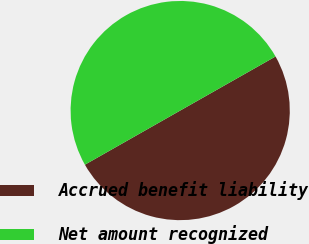Convert chart. <chart><loc_0><loc_0><loc_500><loc_500><pie_chart><fcel>Accrued benefit liability<fcel>Net amount recognized<nl><fcel>49.99%<fcel>50.01%<nl></chart> 